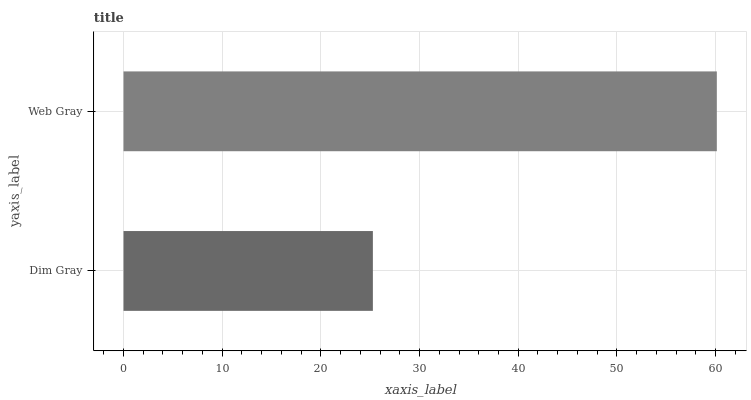Is Dim Gray the minimum?
Answer yes or no. Yes. Is Web Gray the maximum?
Answer yes or no. Yes. Is Web Gray the minimum?
Answer yes or no. No. Is Web Gray greater than Dim Gray?
Answer yes or no. Yes. Is Dim Gray less than Web Gray?
Answer yes or no. Yes. Is Dim Gray greater than Web Gray?
Answer yes or no. No. Is Web Gray less than Dim Gray?
Answer yes or no. No. Is Web Gray the high median?
Answer yes or no. Yes. Is Dim Gray the low median?
Answer yes or no. Yes. Is Dim Gray the high median?
Answer yes or no. No. Is Web Gray the low median?
Answer yes or no. No. 